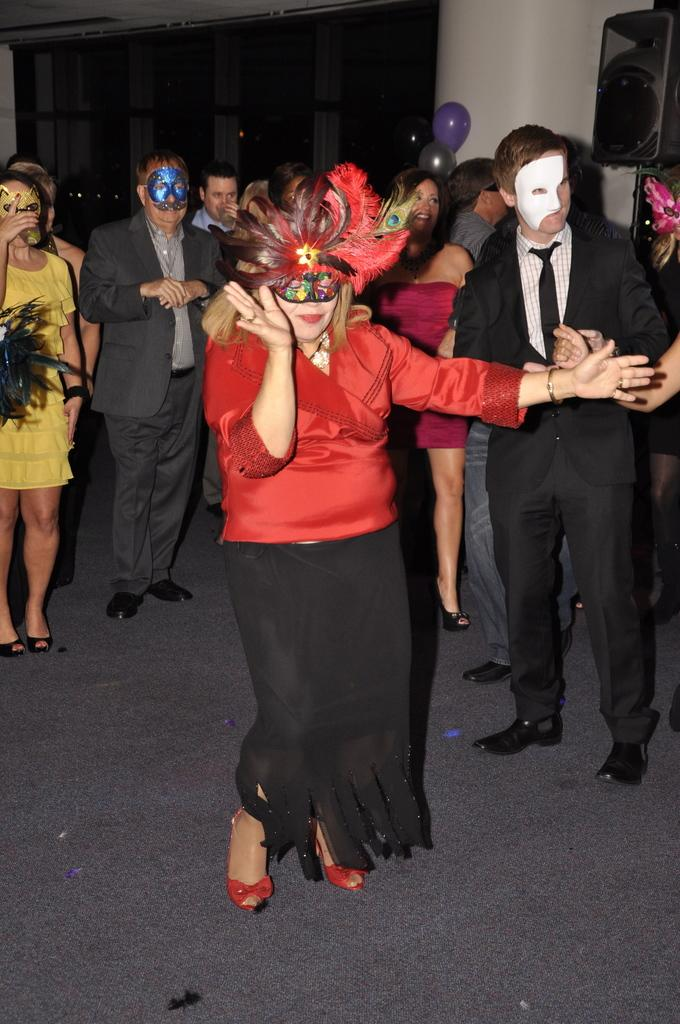Who or what is present in the image? There are people in the image. What are the people wearing? The people are wearing masks. What decorative items can be seen in the image? There are balloons in the image. What architectural feature is present in the image? There is a pillar in the image. What type of walls are visible in the image? There are glass walls in the image. Where is the sun located in the image? The sun is not visible in the image; it is an indoor setting with glass walls. What type of nest can be seen in the image? There is no nest present in the image. 